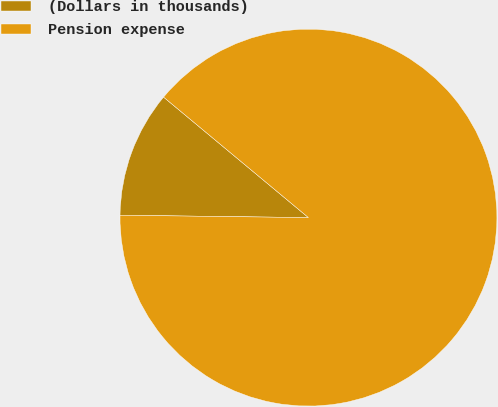<chart> <loc_0><loc_0><loc_500><loc_500><pie_chart><fcel>(Dollars in thousands)<fcel>Pension expense<nl><fcel>10.84%<fcel>89.16%<nl></chart> 